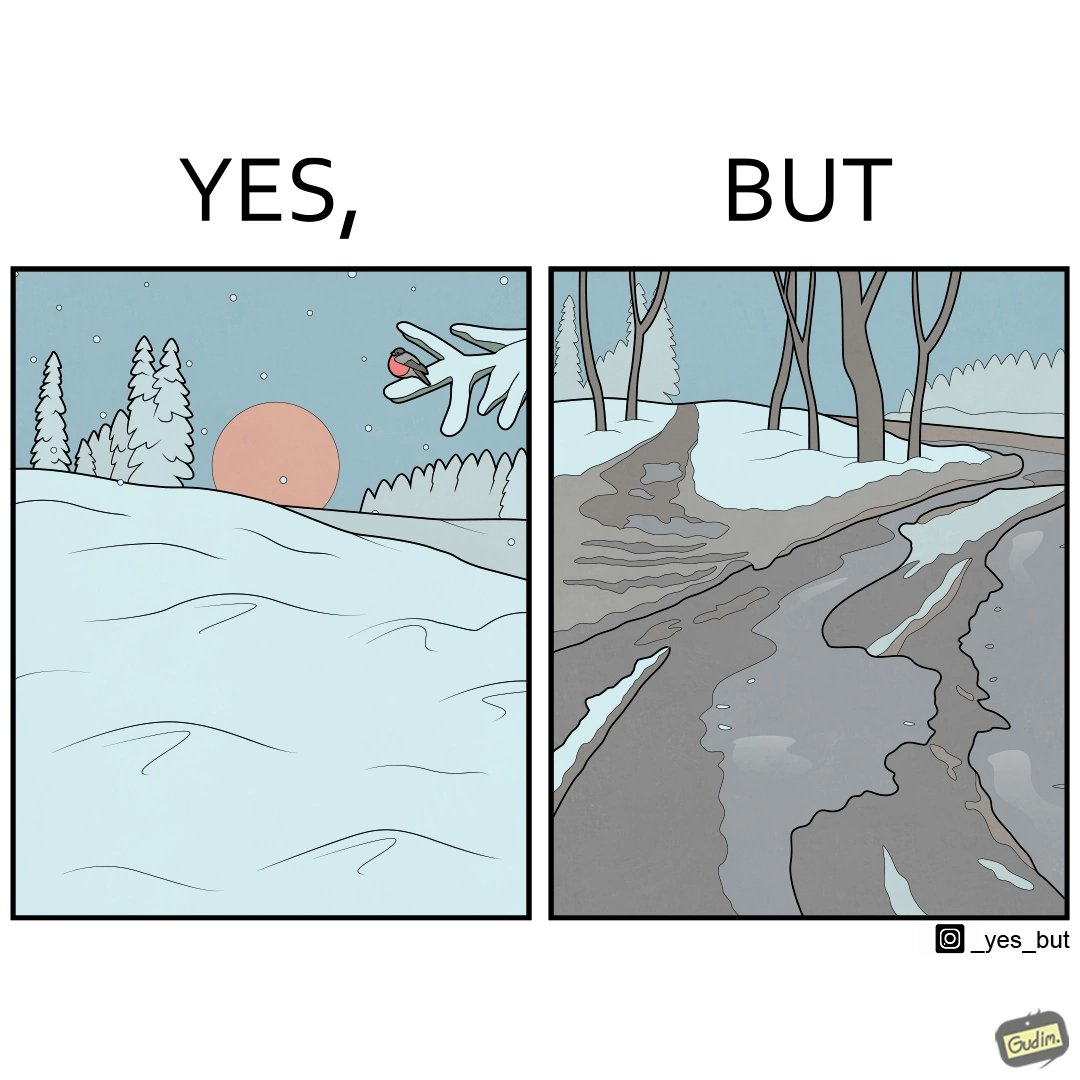Is this image satirical or non-satirical? Yes, this image is satirical. 